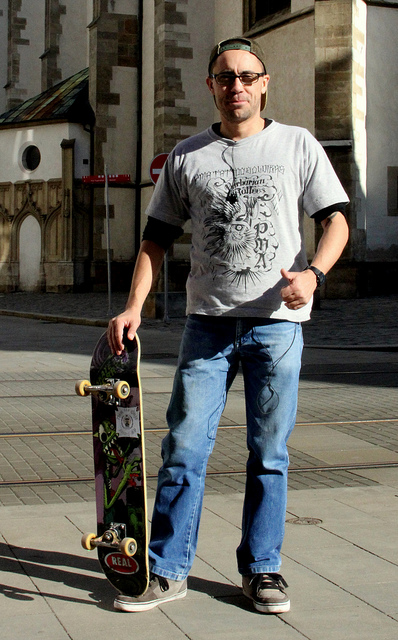Please extract the text content from this image. REAL 